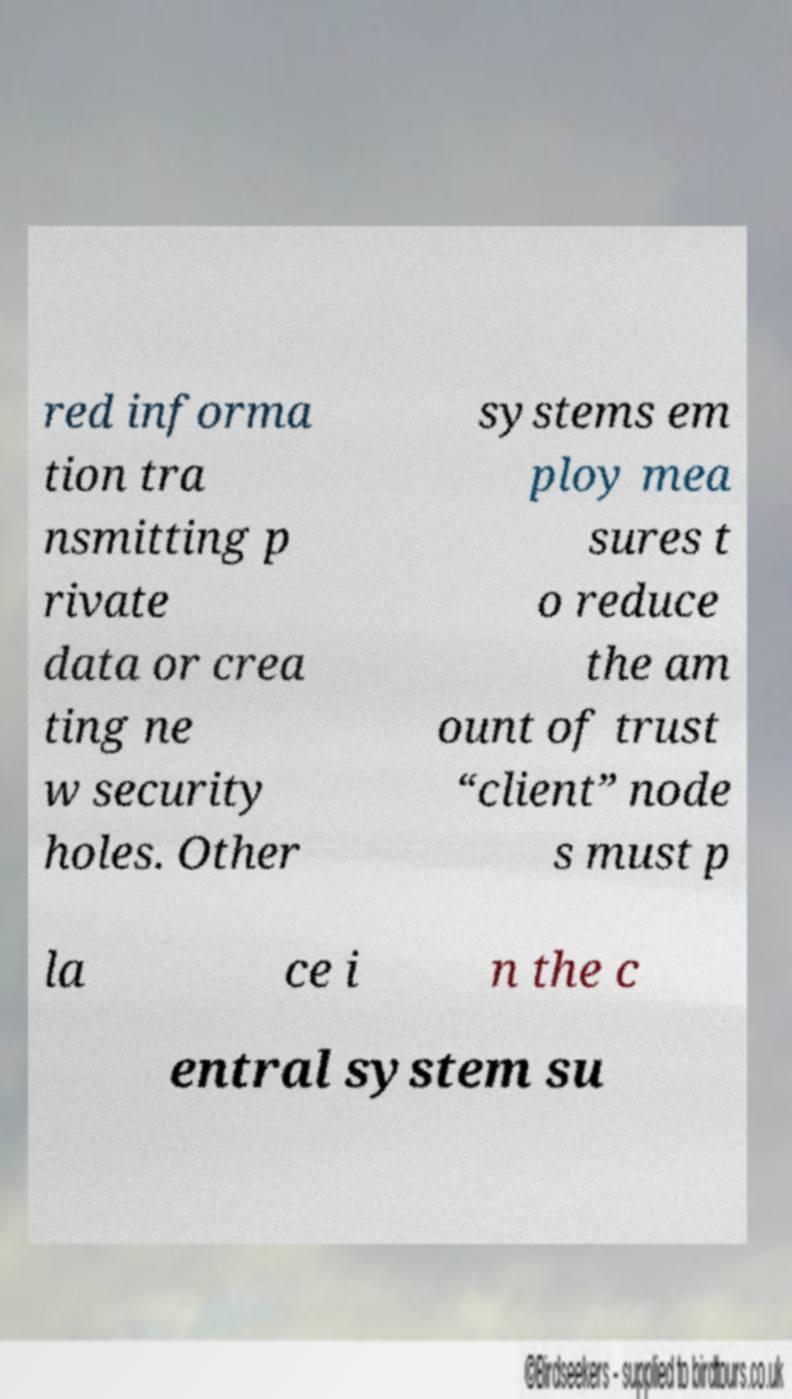Could you extract and type out the text from this image? red informa tion tra nsmitting p rivate data or crea ting ne w security holes. Other systems em ploy mea sures t o reduce the am ount of trust “client” node s must p la ce i n the c entral system su 